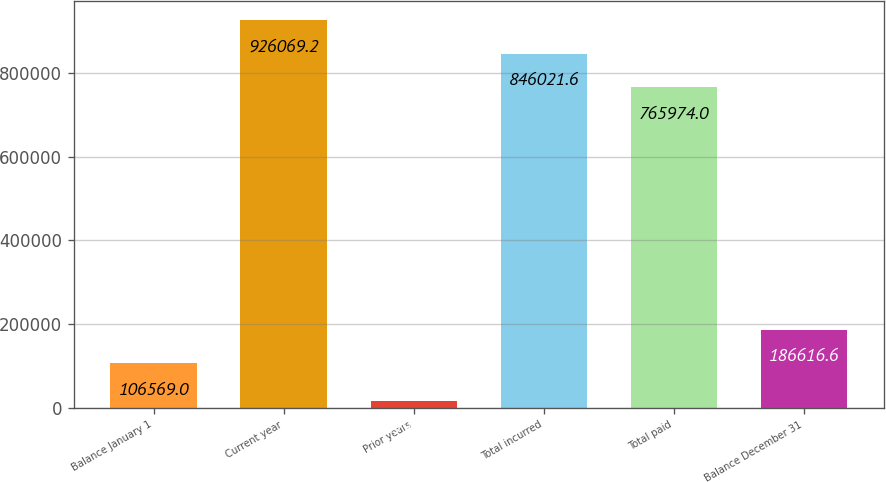<chart> <loc_0><loc_0><loc_500><loc_500><bar_chart><fcel>Balance January 1<fcel>Current year<fcel>Prior years<fcel>Total incurred<fcel>Total paid<fcel>Balance December 31<nl><fcel>106569<fcel>926069<fcel>15942<fcel>846022<fcel>765974<fcel>186617<nl></chart> 